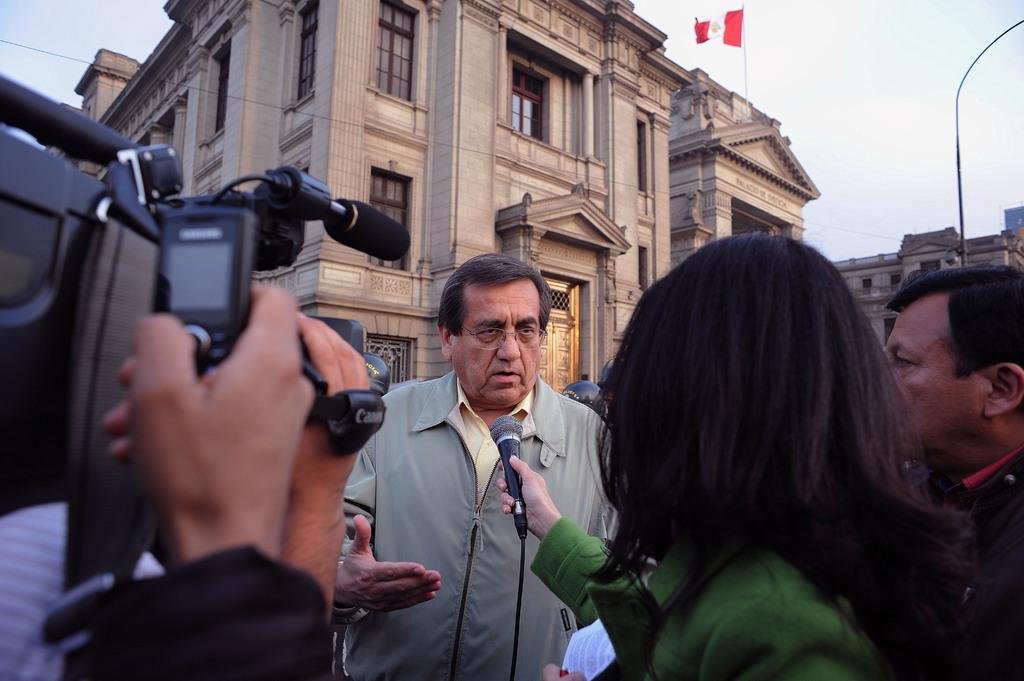Could you give a brief overview of what you see in this image? In this image we can see a few people, among them one is holding the camera and the other one is holding the mic, there are some buildings with windows, we can see a flag on the building, in the background we can see the sky. 